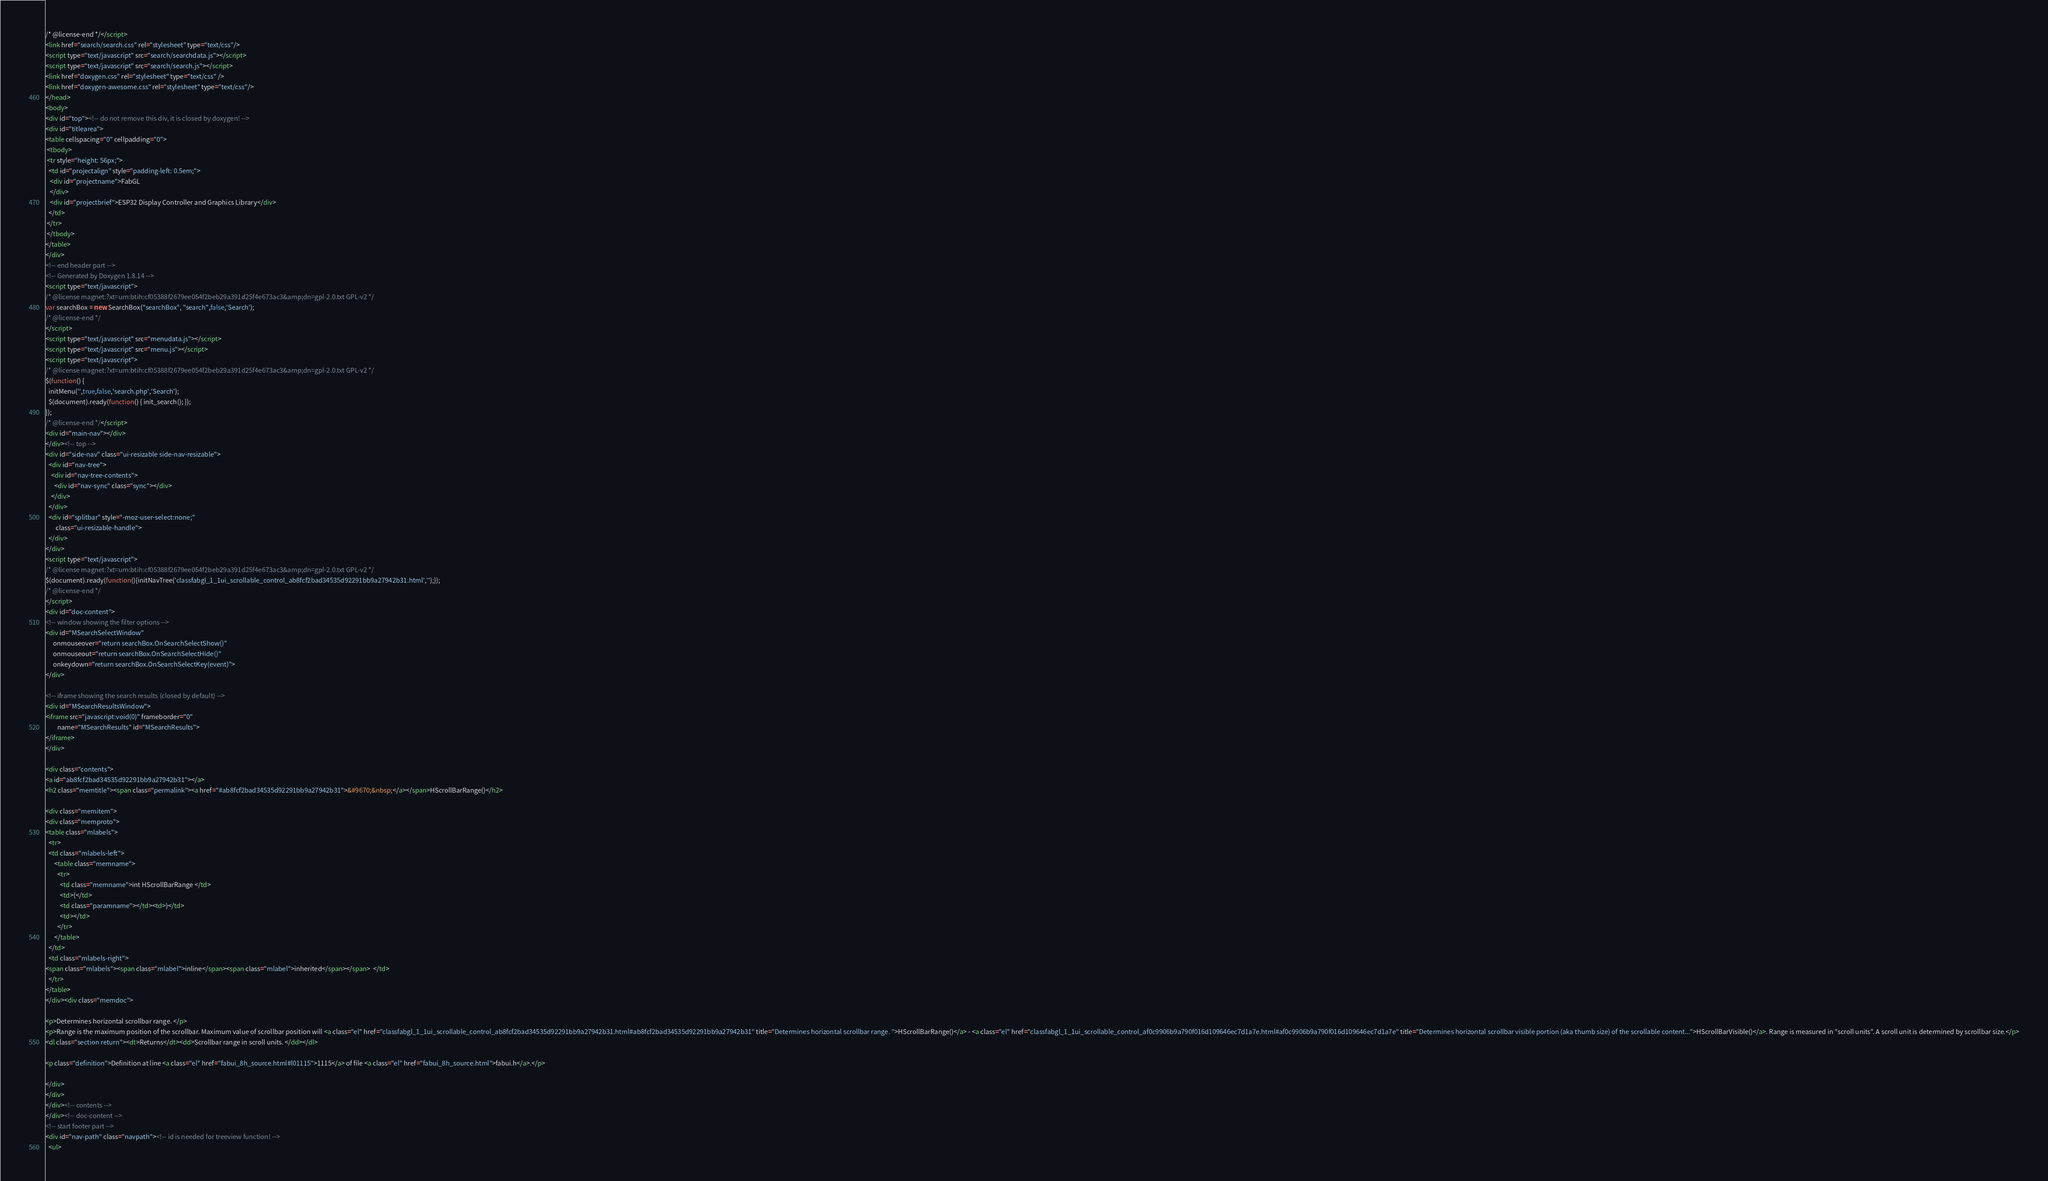<code> <loc_0><loc_0><loc_500><loc_500><_HTML_>/* @license-end */</script>
<link href="search/search.css" rel="stylesheet" type="text/css"/>
<script type="text/javascript" src="search/searchdata.js"></script>
<script type="text/javascript" src="search/search.js"></script>
<link href="doxygen.css" rel="stylesheet" type="text/css" />
<link href="doxygen-awesome.css" rel="stylesheet" type="text/css"/>
</head>
<body>
<div id="top"><!-- do not remove this div, it is closed by doxygen! -->
<div id="titlearea">
<table cellspacing="0" cellpadding="0">
 <tbody>
 <tr style="height: 56px;">
  <td id="projectalign" style="padding-left: 0.5em;">
   <div id="projectname">FabGL
   </div>
   <div id="projectbrief">ESP32 Display Controller and Graphics Library</div>
  </td>
 </tr>
 </tbody>
</table>
</div>
<!-- end header part -->
<!-- Generated by Doxygen 1.8.14 -->
<script type="text/javascript">
/* @license magnet:?xt=urn:btih:cf05388f2679ee054f2beb29a391d25f4e673ac3&amp;dn=gpl-2.0.txt GPL-v2 */
var searchBox = new SearchBox("searchBox", "search",false,'Search');
/* @license-end */
</script>
<script type="text/javascript" src="menudata.js"></script>
<script type="text/javascript" src="menu.js"></script>
<script type="text/javascript">
/* @license magnet:?xt=urn:btih:cf05388f2679ee054f2beb29a391d25f4e673ac3&amp;dn=gpl-2.0.txt GPL-v2 */
$(function() {
  initMenu('',true,false,'search.php','Search');
  $(document).ready(function() { init_search(); });
});
/* @license-end */</script>
<div id="main-nav"></div>
</div><!-- top -->
<div id="side-nav" class="ui-resizable side-nav-resizable">
  <div id="nav-tree">
    <div id="nav-tree-contents">
      <div id="nav-sync" class="sync"></div>
    </div>
  </div>
  <div id="splitbar" style="-moz-user-select:none;" 
       class="ui-resizable-handle">
  </div>
</div>
<script type="text/javascript">
/* @license magnet:?xt=urn:btih:cf05388f2679ee054f2beb29a391d25f4e673ac3&amp;dn=gpl-2.0.txt GPL-v2 */
$(document).ready(function(){initNavTree('classfabgl_1_1ui_scrollable_control_ab8fcf2bad34535d92291bb9a27942b31.html','');});
/* @license-end */
</script>
<div id="doc-content">
<!-- window showing the filter options -->
<div id="MSearchSelectWindow"
     onmouseover="return searchBox.OnSearchSelectShow()"
     onmouseout="return searchBox.OnSearchSelectHide()"
     onkeydown="return searchBox.OnSearchSelectKey(event)">
</div>

<!-- iframe showing the search results (closed by default) -->
<div id="MSearchResultsWindow">
<iframe src="javascript:void(0)" frameborder="0" 
        name="MSearchResults" id="MSearchResults">
</iframe>
</div>

<div class="contents">
<a id="ab8fcf2bad34535d92291bb9a27942b31"></a>
<h2 class="memtitle"><span class="permalink"><a href="#ab8fcf2bad34535d92291bb9a27942b31">&#9670;&nbsp;</a></span>HScrollBarRange()</h2>

<div class="memitem">
<div class="memproto">
<table class="mlabels">
  <tr>
  <td class="mlabels-left">
      <table class="memname">
        <tr>
          <td class="memname">int HScrollBarRange </td>
          <td>(</td>
          <td class="paramname"></td><td>)</td>
          <td></td>
        </tr>
      </table>
  </td>
  <td class="mlabels-right">
<span class="mlabels"><span class="mlabel">inline</span><span class="mlabel">inherited</span></span>  </td>
  </tr>
</table>
</div><div class="memdoc">

<p>Determines horizontal scrollbar range. </p>
<p>Range is the maximum position of the scrollbar. Maximum value of scrollbar position will <a class="el" href="classfabgl_1_1ui_scrollable_control_ab8fcf2bad34535d92291bb9a27942b31.html#ab8fcf2bad34535d92291bb9a27942b31" title="Determines horizontal scrollbar range. ">HScrollBarRange()</a> - <a class="el" href="classfabgl_1_1ui_scrollable_control_af0c9906b9a790f016d109646ec7d1a7e.html#af0c9906b9a790f016d109646ec7d1a7e" title="Determines horizontal scrollbar visible portion (aka thumb size) of the scrollable content...">HScrollBarVisible()</a>. Range is measured in "scroll units". A scroll unit is determined by scrollbar size.</p>
<dl class="section return"><dt>Returns</dt><dd>Scrollbar range in scroll units. </dd></dl>

<p class="definition">Definition at line <a class="el" href="fabui_8h_source.html#l01115">1115</a> of file <a class="el" href="fabui_8h_source.html">fabui.h</a>.</p>

</div>
</div>
</div><!-- contents -->
</div><!-- doc-content -->
<!-- start footer part -->
<div id="nav-path" class="navpath"><!-- id is needed for treeview function! -->
  <ul></code> 